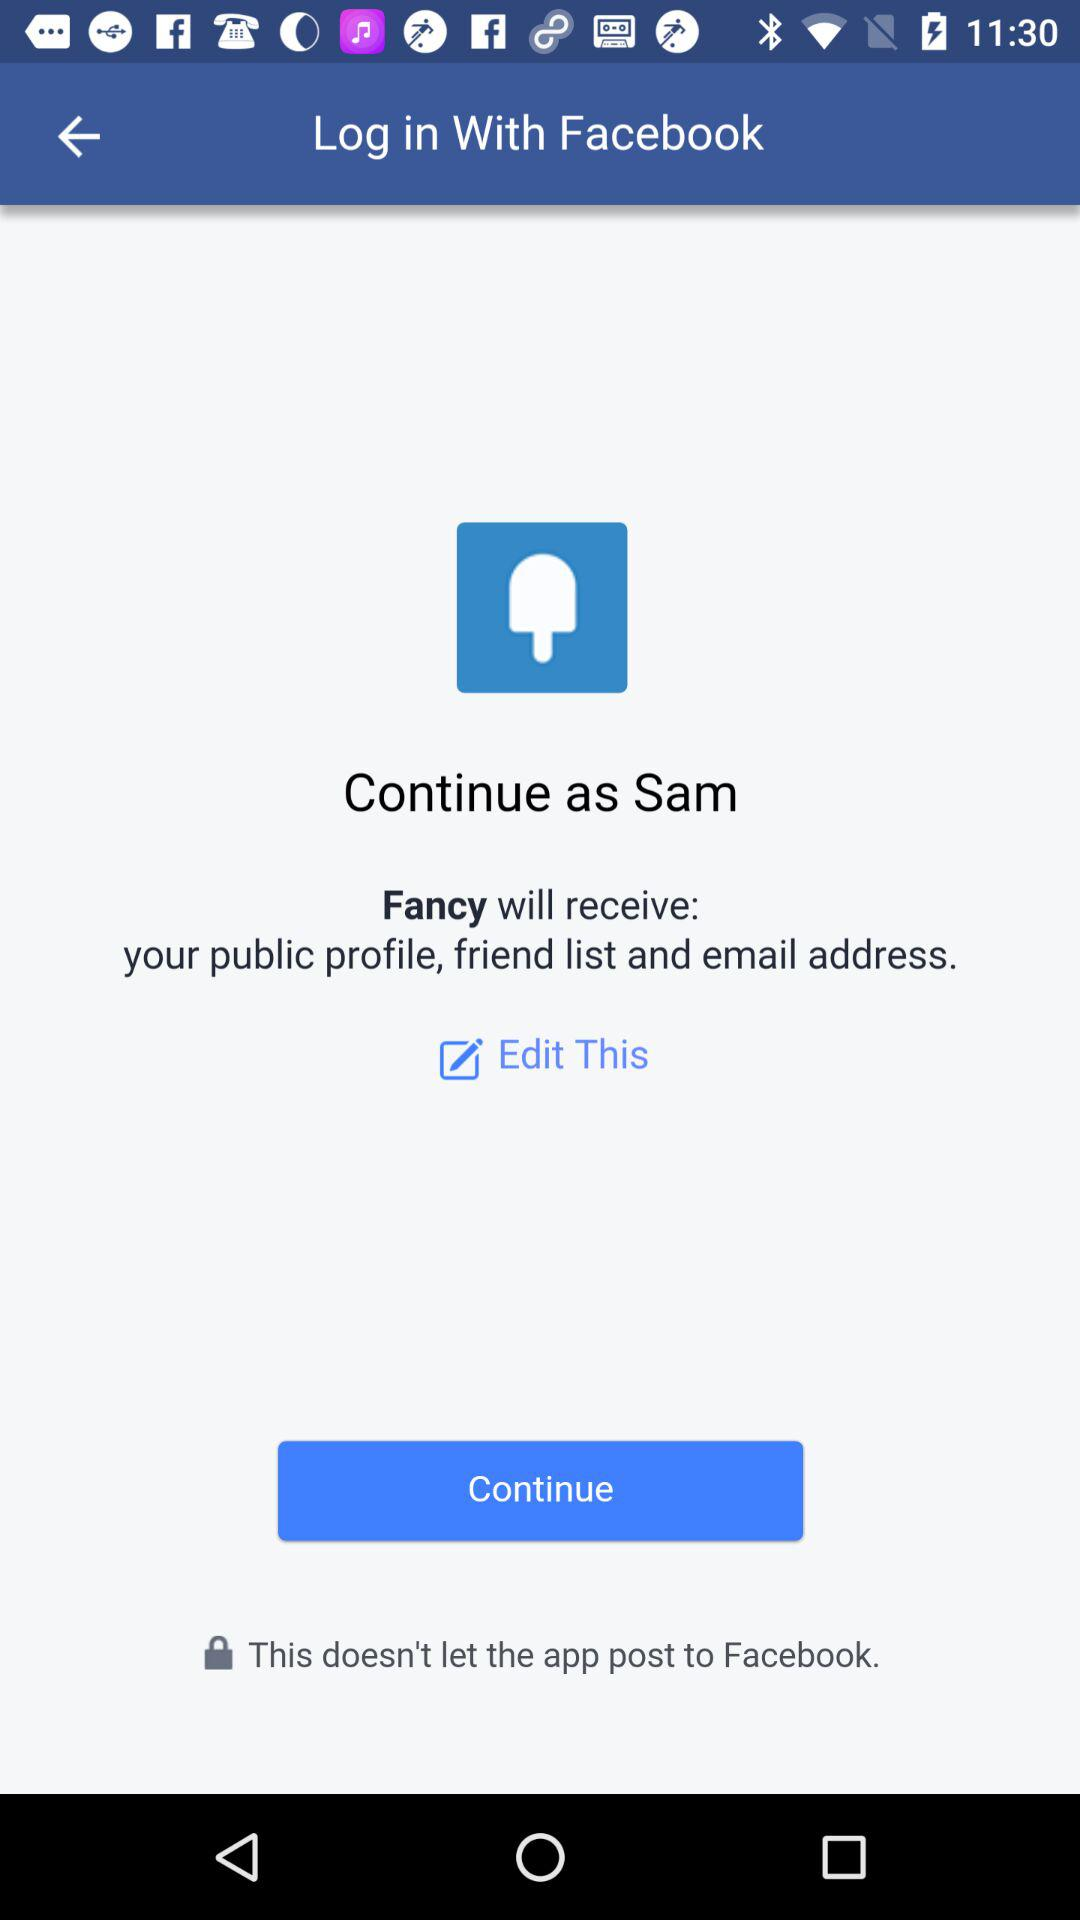Through what application can we log in? We can login through "Facebook". 